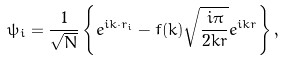Convert formula to latex. <formula><loc_0><loc_0><loc_500><loc_500>\psi _ { i } = \frac { 1 } { \sqrt { N } } \left \{ e ^ { i { k } \cdot { r } _ { i } } - f ( k ) \sqrt { \frac { i \pi } { 2 k r } } e ^ { i k r } \right \} ,</formula> 